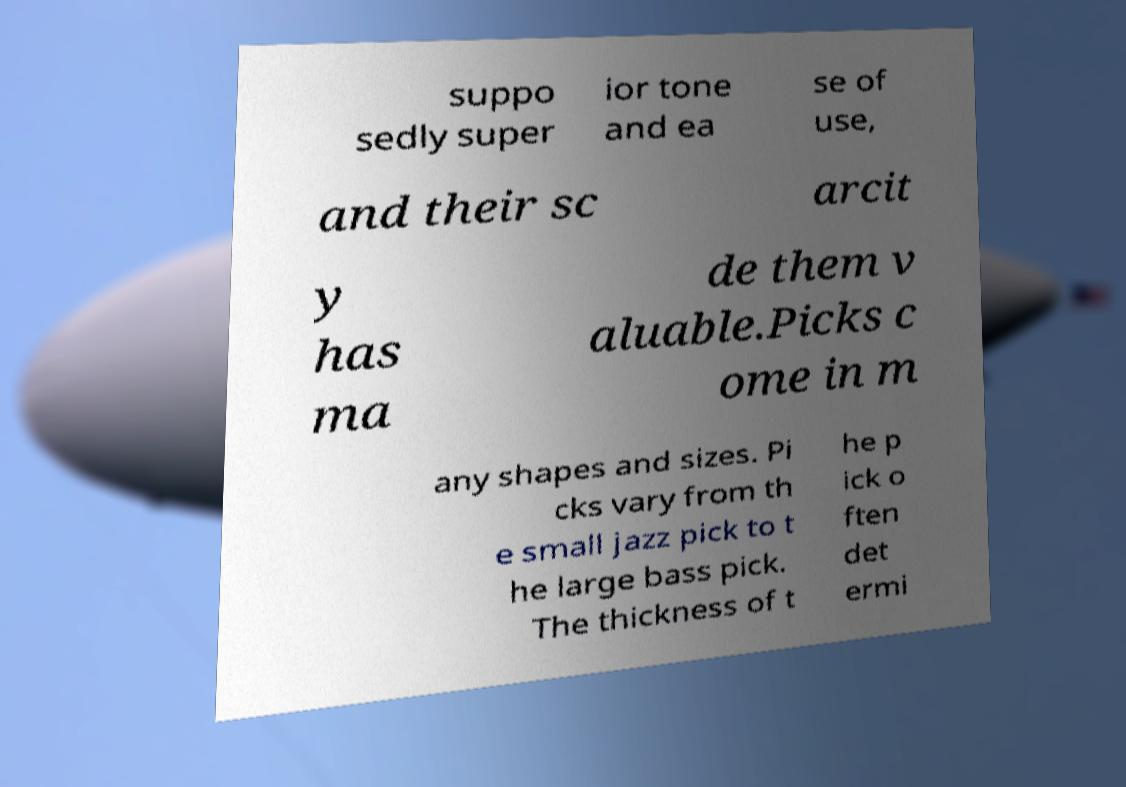Can you read and provide the text displayed in the image?This photo seems to have some interesting text. Can you extract and type it out for me? suppo sedly super ior tone and ea se of use, and their sc arcit y has ma de them v aluable.Picks c ome in m any shapes and sizes. Pi cks vary from th e small jazz pick to t he large bass pick. The thickness of t he p ick o ften det ermi 